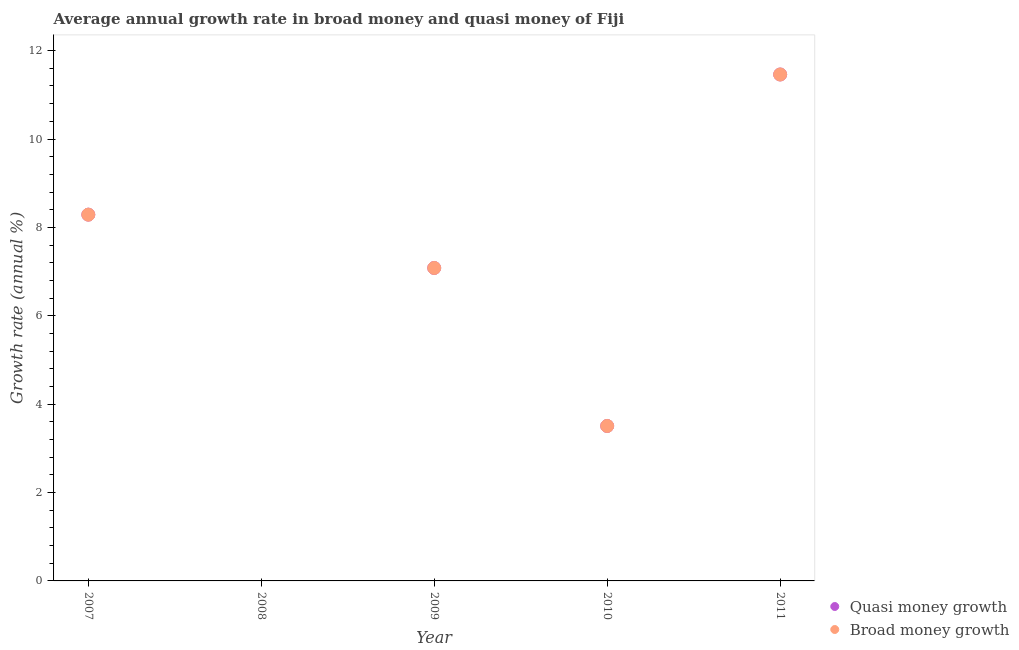What is the annual growth rate in broad money in 2009?
Offer a terse response. 7.08. Across all years, what is the maximum annual growth rate in broad money?
Provide a short and direct response. 11.46. In which year was the annual growth rate in broad money maximum?
Give a very brief answer. 2011. What is the total annual growth rate in broad money in the graph?
Your answer should be very brief. 30.34. What is the difference between the annual growth rate in broad money in 2010 and that in 2011?
Your answer should be compact. -7.95. What is the difference between the annual growth rate in broad money in 2010 and the annual growth rate in quasi money in 2008?
Your answer should be compact. 3.51. What is the average annual growth rate in broad money per year?
Ensure brevity in your answer.  6.07. In the year 2011, what is the difference between the annual growth rate in quasi money and annual growth rate in broad money?
Give a very brief answer. 0. What is the ratio of the annual growth rate in quasi money in 2007 to that in 2011?
Ensure brevity in your answer.  0.72. Is the difference between the annual growth rate in broad money in 2009 and 2010 greater than the difference between the annual growth rate in quasi money in 2009 and 2010?
Provide a succinct answer. No. What is the difference between the highest and the second highest annual growth rate in quasi money?
Offer a very short reply. 3.17. What is the difference between the highest and the lowest annual growth rate in quasi money?
Offer a very short reply. 11.46. In how many years, is the annual growth rate in broad money greater than the average annual growth rate in broad money taken over all years?
Make the answer very short. 3. Is the annual growth rate in quasi money strictly greater than the annual growth rate in broad money over the years?
Give a very brief answer. No. Is the annual growth rate in quasi money strictly less than the annual growth rate in broad money over the years?
Give a very brief answer. No. How many dotlines are there?
Keep it short and to the point. 2. How many years are there in the graph?
Your answer should be very brief. 5. Does the graph contain grids?
Provide a succinct answer. No. Where does the legend appear in the graph?
Keep it short and to the point. Bottom right. What is the title of the graph?
Ensure brevity in your answer.  Average annual growth rate in broad money and quasi money of Fiji. What is the label or title of the X-axis?
Your response must be concise. Year. What is the label or title of the Y-axis?
Give a very brief answer. Growth rate (annual %). What is the Growth rate (annual %) of Quasi money growth in 2007?
Offer a very short reply. 8.29. What is the Growth rate (annual %) in Broad money growth in 2007?
Keep it short and to the point. 8.29. What is the Growth rate (annual %) of Broad money growth in 2008?
Your answer should be compact. 0. What is the Growth rate (annual %) of Quasi money growth in 2009?
Make the answer very short. 7.08. What is the Growth rate (annual %) in Broad money growth in 2009?
Your response must be concise. 7.08. What is the Growth rate (annual %) in Quasi money growth in 2010?
Your answer should be very brief. 3.51. What is the Growth rate (annual %) in Broad money growth in 2010?
Make the answer very short. 3.51. What is the Growth rate (annual %) in Quasi money growth in 2011?
Make the answer very short. 11.46. What is the Growth rate (annual %) of Broad money growth in 2011?
Make the answer very short. 11.46. Across all years, what is the maximum Growth rate (annual %) in Quasi money growth?
Keep it short and to the point. 11.46. Across all years, what is the maximum Growth rate (annual %) in Broad money growth?
Your answer should be compact. 11.46. Across all years, what is the minimum Growth rate (annual %) of Quasi money growth?
Your answer should be compact. 0. Across all years, what is the minimum Growth rate (annual %) of Broad money growth?
Offer a very short reply. 0. What is the total Growth rate (annual %) of Quasi money growth in the graph?
Give a very brief answer. 30.34. What is the total Growth rate (annual %) of Broad money growth in the graph?
Make the answer very short. 30.34. What is the difference between the Growth rate (annual %) of Quasi money growth in 2007 and that in 2009?
Provide a short and direct response. 1.21. What is the difference between the Growth rate (annual %) of Broad money growth in 2007 and that in 2009?
Your response must be concise. 1.21. What is the difference between the Growth rate (annual %) in Quasi money growth in 2007 and that in 2010?
Your answer should be very brief. 4.78. What is the difference between the Growth rate (annual %) of Broad money growth in 2007 and that in 2010?
Your response must be concise. 4.78. What is the difference between the Growth rate (annual %) in Quasi money growth in 2007 and that in 2011?
Your answer should be very brief. -3.17. What is the difference between the Growth rate (annual %) in Broad money growth in 2007 and that in 2011?
Offer a terse response. -3.17. What is the difference between the Growth rate (annual %) of Quasi money growth in 2009 and that in 2010?
Offer a very short reply. 3.58. What is the difference between the Growth rate (annual %) in Broad money growth in 2009 and that in 2010?
Make the answer very short. 3.58. What is the difference between the Growth rate (annual %) in Quasi money growth in 2009 and that in 2011?
Your answer should be compact. -4.38. What is the difference between the Growth rate (annual %) in Broad money growth in 2009 and that in 2011?
Your answer should be very brief. -4.38. What is the difference between the Growth rate (annual %) of Quasi money growth in 2010 and that in 2011?
Give a very brief answer. -7.95. What is the difference between the Growth rate (annual %) of Broad money growth in 2010 and that in 2011?
Offer a very short reply. -7.95. What is the difference between the Growth rate (annual %) of Quasi money growth in 2007 and the Growth rate (annual %) of Broad money growth in 2009?
Give a very brief answer. 1.21. What is the difference between the Growth rate (annual %) in Quasi money growth in 2007 and the Growth rate (annual %) in Broad money growth in 2010?
Offer a very short reply. 4.78. What is the difference between the Growth rate (annual %) in Quasi money growth in 2007 and the Growth rate (annual %) in Broad money growth in 2011?
Offer a very short reply. -3.17. What is the difference between the Growth rate (annual %) of Quasi money growth in 2009 and the Growth rate (annual %) of Broad money growth in 2010?
Your answer should be compact. 3.58. What is the difference between the Growth rate (annual %) in Quasi money growth in 2009 and the Growth rate (annual %) in Broad money growth in 2011?
Ensure brevity in your answer.  -4.38. What is the difference between the Growth rate (annual %) of Quasi money growth in 2010 and the Growth rate (annual %) of Broad money growth in 2011?
Offer a terse response. -7.95. What is the average Growth rate (annual %) of Quasi money growth per year?
Your answer should be compact. 6.07. What is the average Growth rate (annual %) of Broad money growth per year?
Make the answer very short. 6.07. In the year 2009, what is the difference between the Growth rate (annual %) in Quasi money growth and Growth rate (annual %) in Broad money growth?
Your response must be concise. 0. In the year 2010, what is the difference between the Growth rate (annual %) in Quasi money growth and Growth rate (annual %) in Broad money growth?
Offer a very short reply. 0. What is the ratio of the Growth rate (annual %) of Quasi money growth in 2007 to that in 2009?
Make the answer very short. 1.17. What is the ratio of the Growth rate (annual %) in Broad money growth in 2007 to that in 2009?
Your response must be concise. 1.17. What is the ratio of the Growth rate (annual %) in Quasi money growth in 2007 to that in 2010?
Your answer should be very brief. 2.36. What is the ratio of the Growth rate (annual %) of Broad money growth in 2007 to that in 2010?
Give a very brief answer. 2.36. What is the ratio of the Growth rate (annual %) of Quasi money growth in 2007 to that in 2011?
Your answer should be very brief. 0.72. What is the ratio of the Growth rate (annual %) in Broad money growth in 2007 to that in 2011?
Provide a succinct answer. 0.72. What is the ratio of the Growth rate (annual %) of Quasi money growth in 2009 to that in 2010?
Your answer should be very brief. 2.02. What is the ratio of the Growth rate (annual %) of Broad money growth in 2009 to that in 2010?
Provide a short and direct response. 2.02. What is the ratio of the Growth rate (annual %) in Quasi money growth in 2009 to that in 2011?
Keep it short and to the point. 0.62. What is the ratio of the Growth rate (annual %) in Broad money growth in 2009 to that in 2011?
Give a very brief answer. 0.62. What is the ratio of the Growth rate (annual %) of Quasi money growth in 2010 to that in 2011?
Give a very brief answer. 0.31. What is the ratio of the Growth rate (annual %) of Broad money growth in 2010 to that in 2011?
Ensure brevity in your answer.  0.31. What is the difference between the highest and the second highest Growth rate (annual %) of Quasi money growth?
Offer a very short reply. 3.17. What is the difference between the highest and the second highest Growth rate (annual %) in Broad money growth?
Give a very brief answer. 3.17. What is the difference between the highest and the lowest Growth rate (annual %) in Quasi money growth?
Your answer should be very brief. 11.46. What is the difference between the highest and the lowest Growth rate (annual %) of Broad money growth?
Your answer should be very brief. 11.46. 